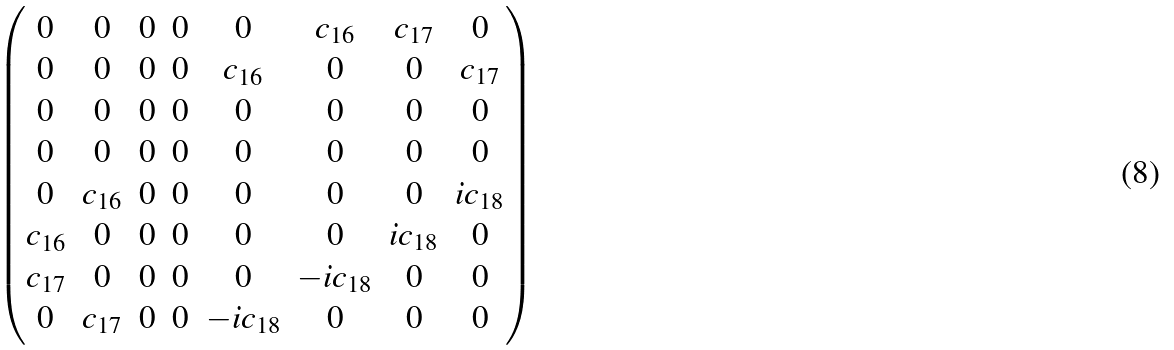<formula> <loc_0><loc_0><loc_500><loc_500>\begin{pmatrix} 0 & 0 & 0 & 0 & 0 & { c _ { 1 6 } } & { c _ { 1 7 } } & 0 \\ 0 & 0 & 0 & 0 & { c _ { 1 6 } } & 0 & 0 & { c _ { 1 7 } } \\ 0 & 0 & 0 & 0 & 0 & 0 & 0 & 0 \\ 0 & 0 & 0 & 0 & 0 & 0 & 0 & 0 \\ 0 & { c _ { 1 6 } } & 0 & 0 & 0 & 0 & 0 & i { c _ { 1 8 } } \\ { c _ { 1 6 } } & 0 & 0 & 0 & 0 & 0 & i { c _ { 1 8 } } & 0 \\ { c _ { 1 7 } } & 0 & 0 & 0 & 0 & - i { c _ { 1 8 } } & 0 & 0 \\ 0 & { c _ { 1 7 } } & 0 & 0 & - i { c _ { 1 8 } } & 0 & 0 & 0 \end{pmatrix}</formula> 